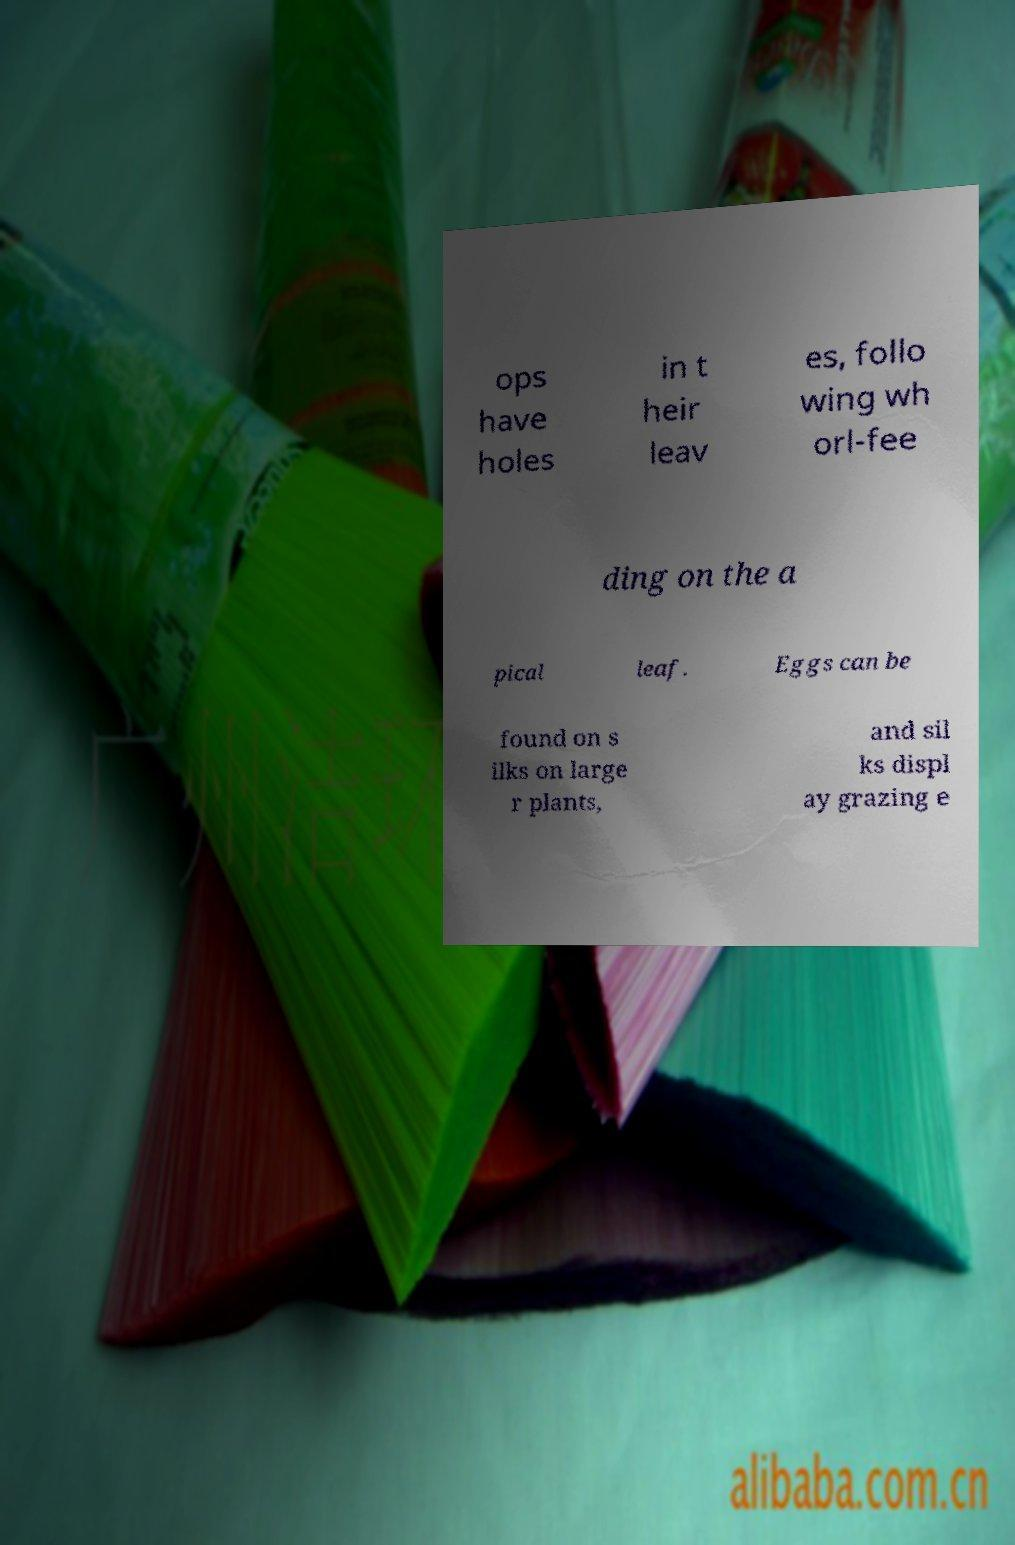For documentation purposes, I need the text within this image transcribed. Could you provide that? ops have holes in t heir leav es, follo wing wh orl-fee ding on the a pical leaf. Eggs can be found on s ilks on large r plants, and sil ks displ ay grazing e 